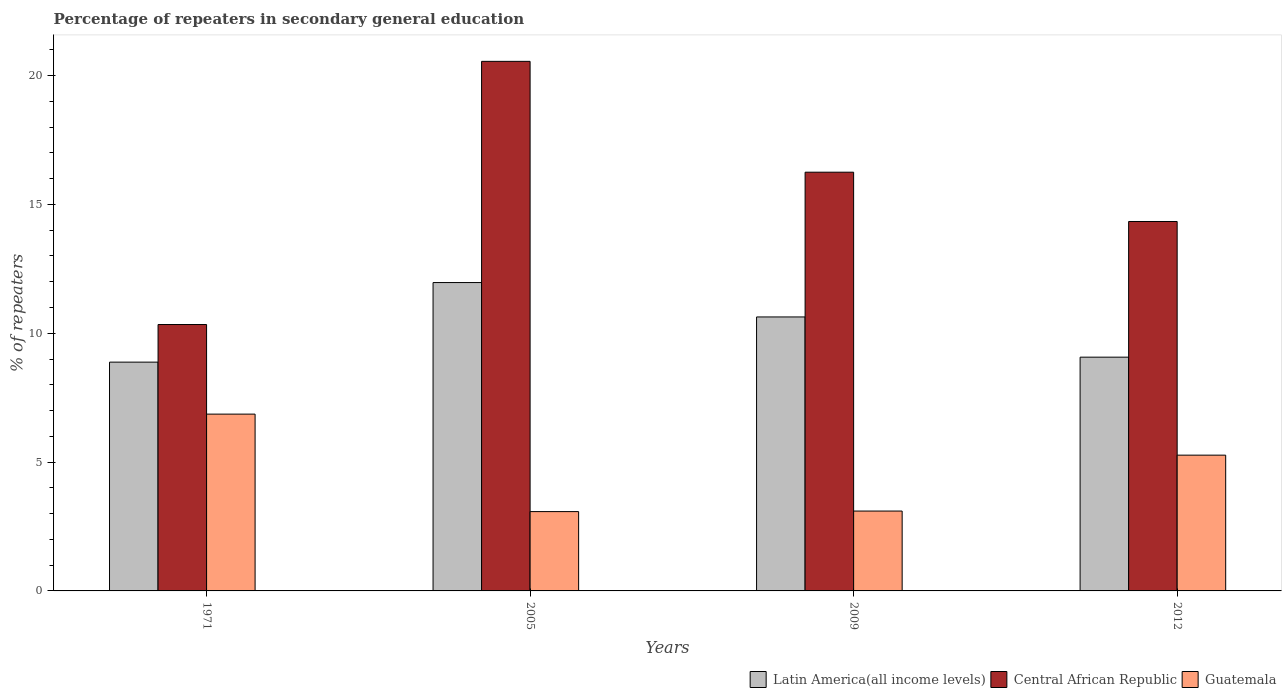How many different coloured bars are there?
Offer a terse response. 3. Are the number of bars on each tick of the X-axis equal?
Offer a terse response. Yes. How many bars are there on the 4th tick from the left?
Keep it short and to the point. 3. What is the label of the 4th group of bars from the left?
Provide a short and direct response. 2012. In how many cases, is the number of bars for a given year not equal to the number of legend labels?
Make the answer very short. 0. What is the percentage of repeaters in secondary general education in Guatemala in 2009?
Make the answer very short. 3.1. Across all years, what is the maximum percentage of repeaters in secondary general education in Latin America(all income levels)?
Your response must be concise. 11.97. Across all years, what is the minimum percentage of repeaters in secondary general education in Central African Republic?
Your response must be concise. 10.34. In which year was the percentage of repeaters in secondary general education in Latin America(all income levels) maximum?
Provide a succinct answer. 2005. What is the total percentage of repeaters in secondary general education in Latin America(all income levels) in the graph?
Provide a short and direct response. 40.55. What is the difference between the percentage of repeaters in secondary general education in Latin America(all income levels) in 1971 and that in 2009?
Your answer should be compact. -1.75. What is the difference between the percentage of repeaters in secondary general education in Guatemala in 2005 and the percentage of repeaters in secondary general education in Latin America(all income levels) in 2009?
Keep it short and to the point. -7.55. What is the average percentage of repeaters in secondary general education in Central African Republic per year?
Ensure brevity in your answer.  15.37. In the year 1971, what is the difference between the percentage of repeaters in secondary general education in Central African Republic and percentage of repeaters in secondary general education in Guatemala?
Your response must be concise. 3.48. What is the ratio of the percentage of repeaters in secondary general education in Guatemala in 1971 to that in 2009?
Provide a succinct answer. 2.21. Is the percentage of repeaters in secondary general education in Central African Republic in 2005 less than that in 2009?
Ensure brevity in your answer.  No. Is the difference between the percentage of repeaters in secondary general education in Central African Republic in 1971 and 2012 greater than the difference between the percentage of repeaters in secondary general education in Guatemala in 1971 and 2012?
Your response must be concise. No. What is the difference between the highest and the second highest percentage of repeaters in secondary general education in Guatemala?
Provide a short and direct response. 1.59. What is the difference between the highest and the lowest percentage of repeaters in secondary general education in Central African Republic?
Make the answer very short. 10.21. In how many years, is the percentage of repeaters in secondary general education in Latin America(all income levels) greater than the average percentage of repeaters in secondary general education in Latin America(all income levels) taken over all years?
Provide a succinct answer. 2. Is the sum of the percentage of repeaters in secondary general education in Latin America(all income levels) in 2005 and 2009 greater than the maximum percentage of repeaters in secondary general education in Central African Republic across all years?
Provide a short and direct response. Yes. What does the 3rd bar from the left in 2012 represents?
Give a very brief answer. Guatemala. What does the 3rd bar from the right in 2012 represents?
Ensure brevity in your answer.  Latin America(all income levels). Is it the case that in every year, the sum of the percentage of repeaters in secondary general education in Guatemala and percentage of repeaters in secondary general education in Central African Republic is greater than the percentage of repeaters in secondary general education in Latin America(all income levels)?
Offer a terse response. Yes. What is the difference between two consecutive major ticks on the Y-axis?
Ensure brevity in your answer.  5. Are the values on the major ticks of Y-axis written in scientific E-notation?
Offer a terse response. No. Does the graph contain any zero values?
Ensure brevity in your answer.  No. Where does the legend appear in the graph?
Your answer should be compact. Bottom right. How many legend labels are there?
Your answer should be compact. 3. How are the legend labels stacked?
Your answer should be very brief. Horizontal. What is the title of the graph?
Provide a short and direct response. Percentage of repeaters in secondary general education. Does "Armenia" appear as one of the legend labels in the graph?
Ensure brevity in your answer.  No. What is the label or title of the Y-axis?
Your response must be concise. % of repeaters. What is the % of repeaters in Latin America(all income levels) in 1971?
Provide a succinct answer. 8.88. What is the % of repeaters in Central African Republic in 1971?
Your answer should be very brief. 10.34. What is the % of repeaters of Guatemala in 1971?
Offer a very short reply. 6.86. What is the % of repeaters of Latin America(all income levels) in 2005?
Keep it short and to the point. 11.97. What is the % of repeaters in Central African Republic in 2005?
Provide a short and direct response. 20.55. What is the % of repeaters of Guatemala in 2005?
Provide a short and direct response. 3.08. What is the % of repeaters in Latin America(all income levels) in 2009?
Your response must be concise. 10.63. What is the % of repeaters of Central African Republic in 2009?
Your response must be concise. 16.25. What is the % of repeaters in Guatemala in 2009?
Offer a terse response. 3.1. What is the % of repeaters in Latin America(all income levels) in 2012?
Ensure brevity in your answer.  9.07. What is the % of repeaters of Central African Republic in 2012?
Provide a short and direct response. 14.34. What is the % of repeaters in Guatemala in 2012?
Your response must be concise. 5.27. Across all years, what is the maximum % of repeaters in Latin America(all income levels)?
Your answer should be very brief. 11.97. Across all years, what is the maximum % of repeaters of Central African Republic?
Keep it short and to the point. 20.55. Across all years, what is the maximum % of repeaters of Guatemala?
Offer a terse response. 6.86. Across all years, what is the minimum % of repeaters of Latin America(all income levels)?
Provide a succinct answer. 8.88. Across all years, what is the minimum % of repeaters in Central African Republic?
Your response must be concise. 10.34. Across all years, what is the minimum % of repeaters in Guatemala?
Give a very brief answer. 3.08. What is the total % of repeaters of Latin America(all income levels) in the graph?
Ensure brevity in your answer.  40.55. What is the total % of repeaters in Central African Republic in the graph?
Your response must be concise. 61.48. What is the total % of repeaters in Guatemala in the graph?
Offer a terse response. 18.31. What is the difference between the % of repeaters in Latin America(all income levels) in 1971 and that in 2005?
Ensure brevity in your answer.  -3.09. What is the difference between the % of repeaters of Central African Republic in 1971 and that in 2005?
Offer a terse response. -10.21. What is the difference between the % of repeaters in Guatemala in 1971 and that in 2005?
Your answer should be very brief. 3.78. What is the difference between the % of repeaters in Latin America(all income levels) in 1971 and that in 2009?
Offer a terse response. -1.75. What is the difference between the % of repeaters in Central African Republic in 1971 and that in 2009?
Your answer should be very brief. -5.91. What is the difference between the % of repeaters of Guatemala in 1971 and that in 2009?
Give a very brief answer. 3.76. What is the difference between the % of repeaters of Latin America(all income levels) in 1971 and that in 2012?
Keep it short and to the point. -0.19. What is the difference between the % of repeaters in Central African Republic in 1971 and that in 2012?
Your answer should be very brief. -4. What is the difference between the % of repeaters in Guatemala in 1971 and that in 2012?
Offer a terse response. 1.59. What is the difference between the % of repeaters in Latin America(all income levels) in 2005 and that in 2009?
Offer a terse response. 1.33. What is the difference between the % of repeaters of Central African Republic in 2005 and that in 2009?
Your answer should be very brief. 4.3. What is the difference between the % of repeaters of Guatemala in 2005 and that in 2009?
Make the answer very short. -0.02. What is the difference between the % of repeaters in Latin America(all income levels) in 2005 and that in 2012?
Provide a short and direct response. 2.9. What is the difference between the % of repeaters in Central African Republic in 2005 and that in 2012?
Offer a terse response. 6.22. What is the difference between the % of repeaters in Guatemala in 2005 and that in 2012?
Keep it short and to the point. -2.19. What is the difference between the % of repeaters in Latin America(all income levels) in 2009 and that in 2012?
Your response must be concise. 1.56. What is the difference between the % of repeaters in Central African Republic in 2009 and that in 2012?
Give a very brief answer. 1.91. What is the difference between the % of repeaters of Guatemala in 2009 and that in 2012?
Provide a short and direct response. -2.17. What is the difference between the % of repeaters of Latin America(all income levels) in 1971 and the % of repeaters of Central African Republic in 2005?
Ensure brevity in your answer.  -11.67. What is the difference between the % of repeaters of Latin America(all income levels) in 1971 and the % of repeaters of Guatemala in 2005?
Your answer should be compact. 5.8. What is the difference between the % of repeaters in Central African Republic in 1971 and the % of repeaters in Guatemala in 2005?
Your answer should be very brief. 7.26. What is the difference between the % of repeaters of Latin America(all income levels) in 1971 and the % of repeaters of Central African Republic in 2009?
Make the answer very short. -7.37. What is the difference between the % of repeaters in Latin America(all income levels) in 1971 and the % of repeaters in Guatemala in 2009?
Keep it short and to the point. 5.78. What is the difference between the % of repeaters of Central African Republic in 1971 and the % of repeaters of Guatemala in 2009?
Offer a very short reply. 7.24. What is the difference between the % of repeaters in Latin America(all income levels) in 1971 and the % of repeaters in Central African Republic in 2012?
Your answer should be compact. -5.46. What is the difference between the % of repeaters in Latin America(all income levels) in 1971 and the % of repeaters in Guatemala in 2012?
Give a very brief answer. 3.61. What is the difference between the % of repeaters in Central African Republic in 1971 and the % of repeaters in Guatemala in 2012?
Give a very brief answer. 5.07. What is the difference between the % of repeaters in Latin America(all income levels) in 2005 and the % of repeaters in Central African Republic in 2009?
Provide a succinct answer. -4.28. What is the difference between the % of repeaters in Latin America(all income levels) in 2005 and the % of repeaters in Guatemala in 2009?
Offer a terse response. 8.87. What is the difference between the % of repeaters in Central African Republic in 2005 and the % of repeaters in Guatemala in 2009?
Provide a short and direct response. 17.45. What is the difference between the % of repeaters of Latin America(all income levels) in 2005 and the % of repeaters of Central African Republic in 2012?
Offer a terse response. -2.37. What is the difference between the % of repeaters of Latin America(all income levels) in 2005 and the % of repeaters of Guatemala in 2012?
Your answer should be very brief. 6.7. What is the difference between the % of repeaters of Central African Republic in 2005 and the % of repeaters of Guatemala in 2012?
Offer a very short reply. 15.28. What is the difference between the % of repeaters of Latin America(all income levels) in 2009 and the % of repeaters of Central African Republic in 2012?
Offer a terse response. -3.7. What is the difference between the % of repeaters in Latin America(all income levels) in 2009 and the % of repeaters in Guatemala in 2012?
Your answer should be very brief. 5.36. What is the difference between the % of repeaters in Central African Republic in 2009 and the % of repeaters in Guatemala in 2012?
Your answer should be compact. 10.98. What is the average % of repeaters of Latin America(all income levels) per year?
Give a very brief answer. 10.14. What is the average % of repeaters in Central African Republic per year?
Offer a very short reply. 15.37. What is the average % of repeaters in Guatemala per year?
Offer a very short reply. 4.58. In the year 1971, what is the difference between the % of repeaters of Latin America(all income levels) and % of repeaters of Central African Republic?
Provide a succinct answer. -1.46. In the year 1971, what is the difference between the % of repeaters of Latin America(all income levels) and % of repeaters of Guatemala?
Your answer should be very brief. 2.02. In the year 1971, what is the difference between the % of repeaters in Central African Republic and % of repeaters in Guatemala?
Give a very brief answer. 3.48. In the year 2005, what is the difference between the % of repeaters of Latin America(all income levels) and % of repeaters of Central African Republic?
Offer a terse response. -8.59. In the year 2005, what is the difference between the % of repeaters in Latin America(all income levels) and % of repeaters in Guatemala?
Your answer should be compact. 8.89. In the year 2005, what is the difference between the % of repeaters in Central African Republic and % of repeaters in Guatemala?
Provide a short and direct response. 17.48. In the year 2009, what is the difference between the % of repeaters of Latin America(all income levels) and % of repeaters of Central African Republic?
Make the answer very short. -5.62. In the year 2009, what is the difference between the % of repeaters of Latin America(all income levels) and % of repeaters of Guatemala?
Provide a succinct answer. 7.53. In the year 2009, what is the difference between the % of repeaters in Central African Republic and % of repeaters in Guatemala?
Offer a terse response. 13.15. In the year 2012, what is the difference between the % of repeaters of Latin America(all income levels) and % of repeaters of Central African Republic?
Make the answer very short. -5.27. In the year 2012, what is the difference between the % of repeaters in Latin America(all income levels) and % of repeaters in Guatemala?
Your answer should be compact. 3.8. In the year 2012, what is the difference between the % of repeaters in Central African Republic and % of repeaters in Guatemala?
Your response must be concise. 9.07. What is the ratio of the % of repeaters in Latin America(all income levels) in 1971 to that in 2005?
Provide a succinct answer. 0.74. What is the ratio of the % of repeaters in Central African Republic in 1971 to that in 2005?
Offer a very short reply. 0.5. What is the ratio of the % of repeaters of Guatemala in 1971 to that in 2005?
Offer a terse response. 2.23. What is the ratio of the % of repeaters of Latin America(all income levels) in 1971 to that in 2009?
Your response must be concise. 0.84. What is the ratio of the % of repeaters in Central African Republic in 1971 to that in 2009?
Make the answer very short. 0.64. What is the ratio of the % of repeaters in Guatemala in 1971 to that in 2009?
Give a very brief answer. 2.21. What is the ratio of the % of repeaters in Latin America(all income levels) in 1971 to that in 2012?
Make the answer very short. 0.98. What is the ratio of the % of repeaters in Central African Republic in 1971 to that in 2012?
Your answer should be very brief. 0.72. What is the ratio of the % of repeaters in Guatemala in 1971 to that in 2012?
Provide a succinct answer. 1.3. What is the ratio of the % of repeaters in Latin America(all income levels) in 2005 to that in 2009?
Provide a succinct answer. 1.13. What is the ratio of the % of repeaters in Central African Republic in 2005 to that in 2009?
Provide a short and direct response. 1.26. What is the ratio of the % of repeaters in Guatemala in 2005 to that in 2009?
Your response must be concise. 0.99. What is the ratio of the % of repeaters of Latin America(all income levels) in 2005 to that in 2012?
Give a very brief answer. 1.32. What is the ratio of the % of repeaters in Central African Republic in 2005 to that in 2012?
Keep it short and to the point. 1.43. What is the ratio of the % of repeaters in Guatemala in 2005 to that in 2012?
Keep it short and to the point. 0.58. What is the ratio of the % of repeaters of Latin America(all income levels) in 2009 to that in 2012?
Offer a terse response. 1.17. What is the ratio of the % of repeaters in Central African Republic in 2009 to that in 2012?
Provide a succinct answer. 1.13. What is the ratio of the % of repeaters of Guatemala in 2009 to that in 2012?
Provide a short and direct response. 0.59. What is the difference between the highest and the second highest % of repeaters in Latin America(all income levels)?
Make the answer very short. 1.33. What is the difference between the highest and the second highest % of repeaters in Central African Republic?
Offer a terse response. 4.3. What is the difference between the highest and the second highest % of repeaters of Guatemala?
Provide a succinct answer. 1.59. What is the difference between the highest and the lowest % of repeaters in Latin America(all income levels)?
Make the answer very short. 3.09. What is the difference between the highest and the lowest % of repeaters of Central African Republic?
Ensure brevity in your answer.  10.21. What is the difference between the highest and the lowest % of repeaters in Guatemala?
Keep it short and to the point. 3.78. 